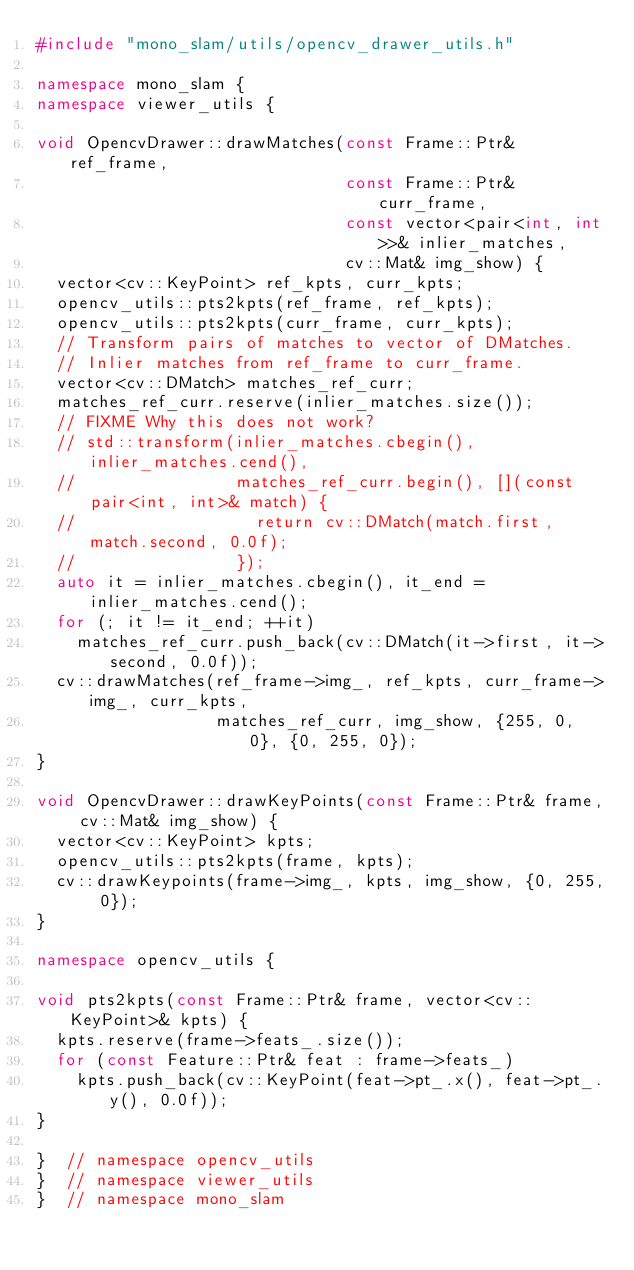Convert code to text. <code><loc_0><loc_0><loc_500><loc_500><_C++_>#include "mono_slam/utils/opencv_drawer_utils.h"

namespace mono_slam {
namespace viewer_utils {

void OpencvDrawer::drawMatches(const Frame::Ptr& ref_frame,
                               const Frame::Ptr& curr_frame,
                               const vector<pair<int, int>>& inlier_matches,
                               cv::Mat& img_show) {
  vector<cv::KeyPoint> ref_kpts, curr_kpts;
  opencv_utils::pts2kpts(ref_frame, ref_kpts);
  opencv_utils::pts2kpts(curr_frame, curr_kpts);
  // Transform pairs of matches to vector of DMatches.
  // Inlier matches from ref_frame to curr_frame.
  vector<cv::DMatch> matches_ref_curr;
  matches_ref_curr.reserve(inlier_matches.size());
  // FIXME Why this does not work?
  // std::transform(inlier_matches.cbegin(), inlier_matches.cend(),
  //                matches_ref_curr.begin(), [](const pair<int, int>& match) {
  //                  return cv::DMatch(match.first, match.second, 0.0f);
  //                });
  auto it = inlier_matches.cbegin(), it_end = inlier_matches.cend();
  for (; it != it_end; ++it)
    matches_ref_curr.push_back(cv::DMatch(it->first, it->second, 0.0f));
  cv::drawMatches(ref_frame->img_, ref_kpts, curr_frame->img_, curr_kpts,
                  matches_ref_curr, img_show, {255, 0, 0}, {0, 255, 0});
}

void OpencvDrawer::drawKeyPoints(const Frame::Ptr& frame, cv::Mat& img_show) {
  vector<cv::KeyPoint> kpts;
  opencv_utils::pts2kpts(frame, kpts);
  cv::drawKeypoints(frame->img_, kpts, img_show, {0, 255, 0});
}

namespace opencv_utils {

void pts2kpts(const Frame::Ptr& frame, vector<cv::KeyPoint>& kpts) {
  kpts.reserve(frame->feats_.size());
  for (const Feature::Ptr& feat : frame->feats_)
    kpts.push_back(cv::KeyPoint(feat->pt_.x(), feat->pt_.y(), 0.0f));
}

}  // namespace opencv_utils
}  // namespace viewer_utils
}  // namespace mono_slam
</code> 